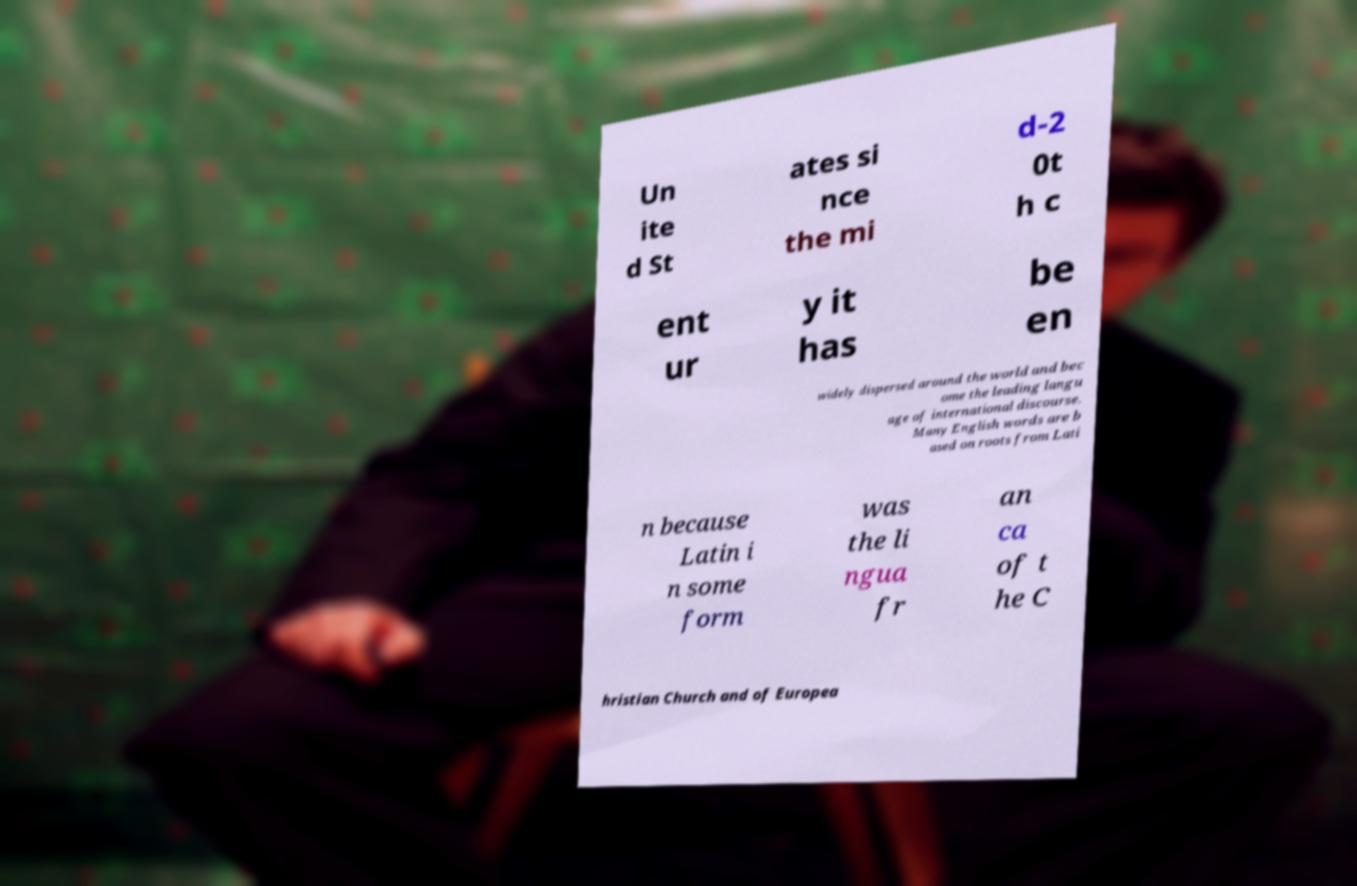What messages or text are displayed in this image? I need them in a readable, typed format. Un ite d St ates si nce the mi d-2 0t h c ent ur y it has be en widely dispersed around the world and bec ome the leading langu age of international discourse. Many English words are b ased on roots from Lati n because Latin i n some form was the li ngua fr an ca of t he C hristian Church and of Europea 